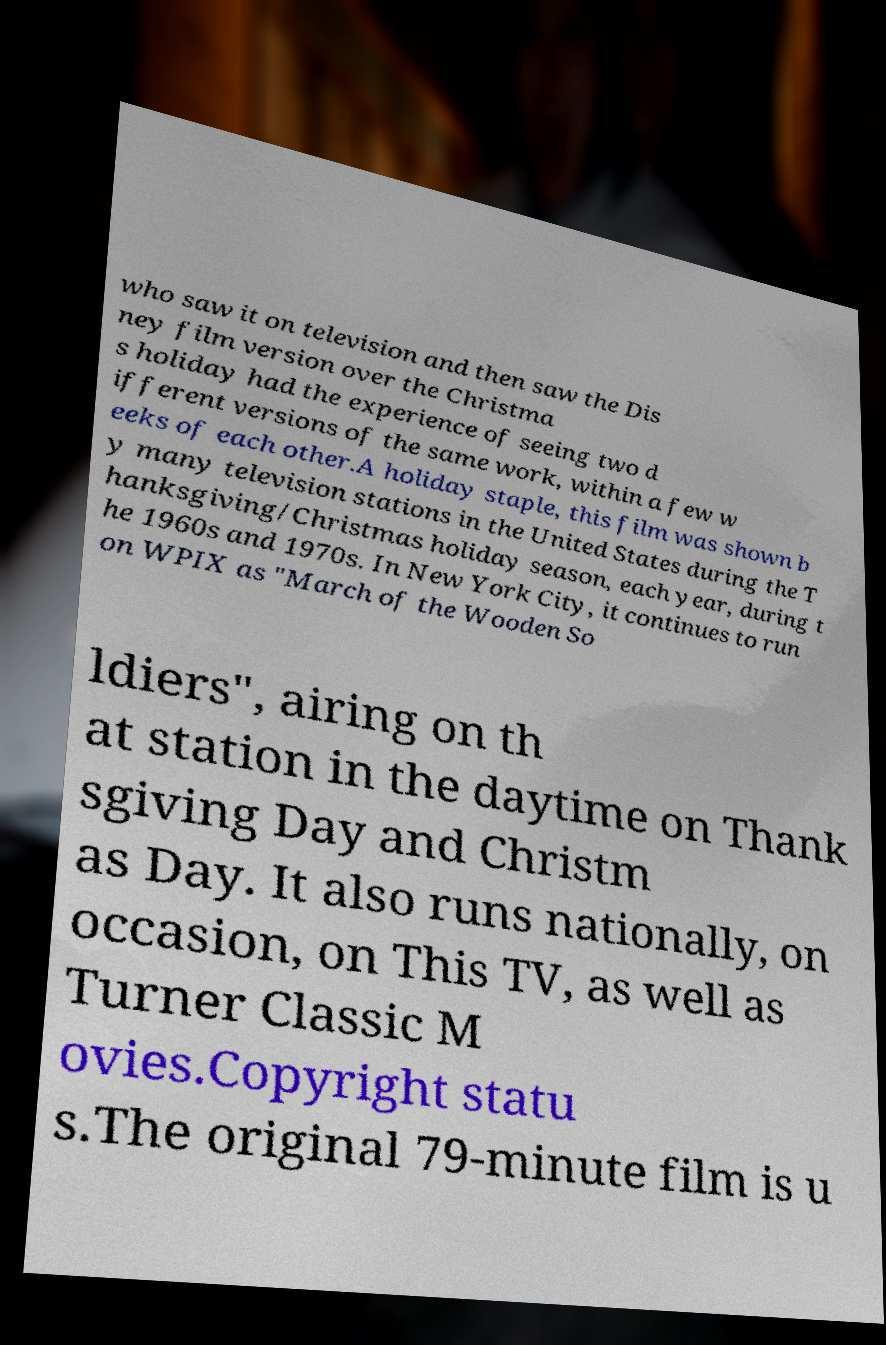I need the written content from this picture converted into text. Can you do that? who saw it on television and then saw the Dis ney film version over the Christma s holiday had the experience of seeing two d ifferent versions of the same work, within a few w eeks of each other.A holiday staple, this film was shown b y many television stations in the United States during the T hanksgiving/Christmas holiday season, each year, during t he 1960s and 1970s. In New York City, it continues to run on WPIX as "March of the Wooden So ldiers", airing on th at station in the daytime on Thank sgiving Day and Christm as Day. It also runs nationally, on occasion, on This TV, as well as Turner Classic M ovies.Copyright statu s.The original 79-minute film is u 